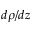Convert formula to latex. <formula><loc_0><loc_0><loc_500><loc_500>d \rho / d z</formula> 